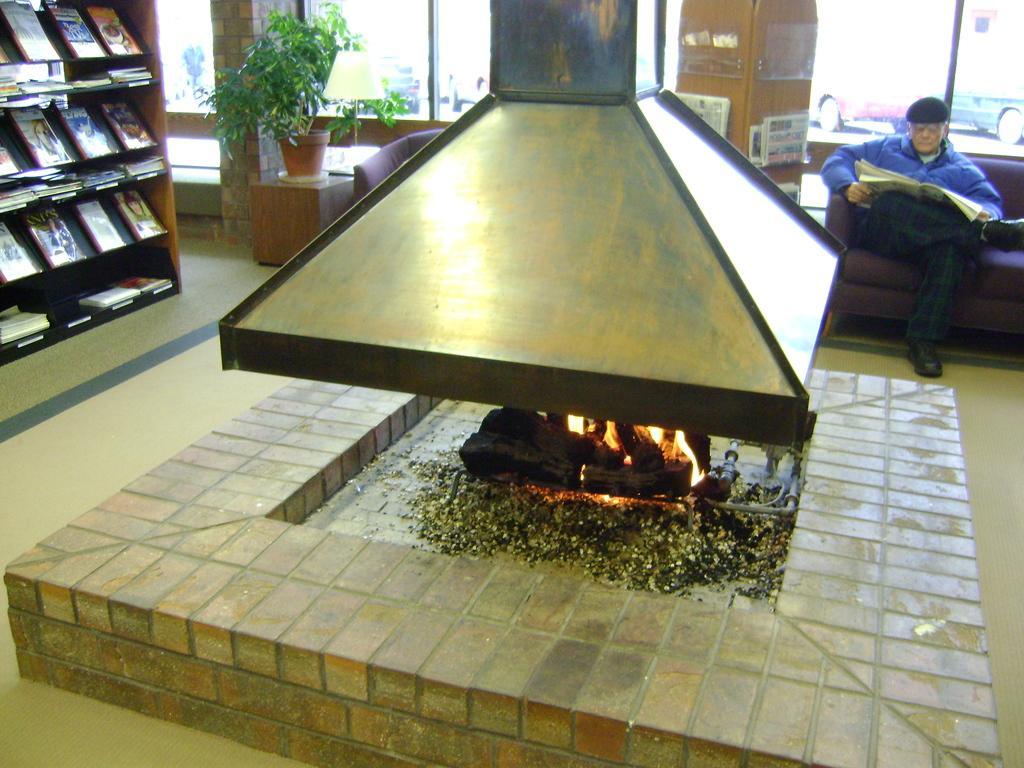Could you give a brief overview of what you see in this image? In the image there is a brick platform with fire. Above the fire there is a chimney. On the left side of the image there is a cupboard with books in it. On the right side of the image there is a man sitting on the sofa and holding the paper in his hand and there is a hat on his head. In the background there is a pot with plant on the wooden item and also there is a sofa. There are glass doors. Behind the glass door on the right side there are cars. 